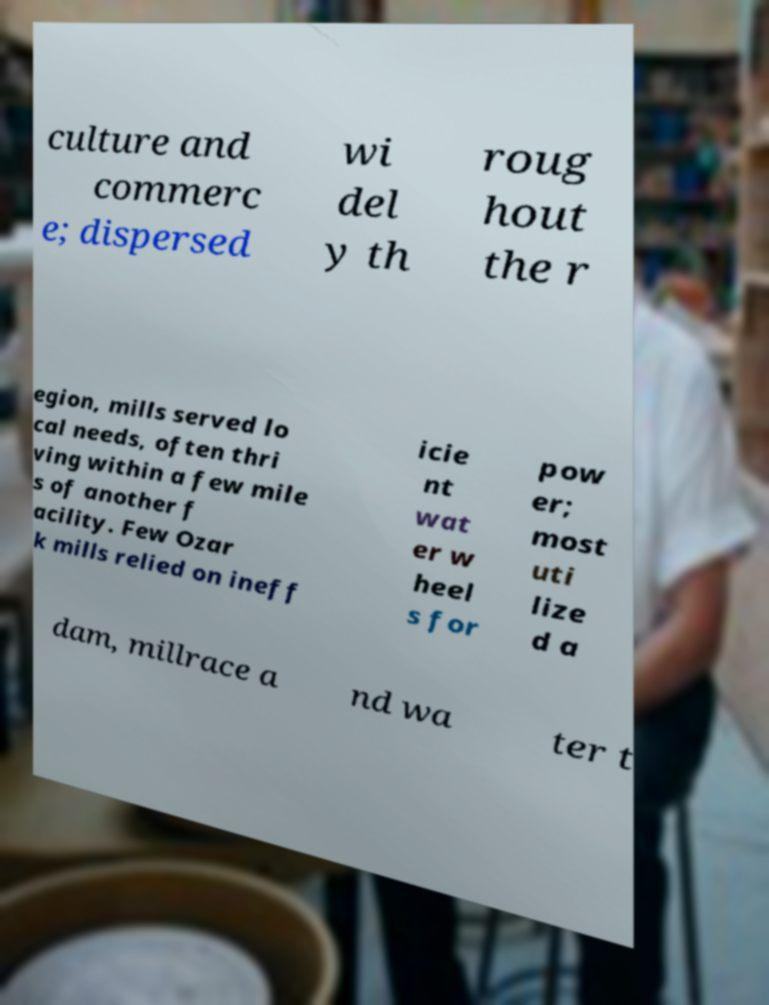Can you read and provide the text displayed in the image?This photo seems to have some interesting text. Can you extract and type it out for me? culture and commerc e; dispersed wi del y th roug hout the r egion, mills served lo cal needs, often thri ving within a few mile s of another f acility. Few Ozar k mills relied on ineff icie nt wat er w heel s for pow er; most uti lize d a dam, millrace a nd wa ter t 